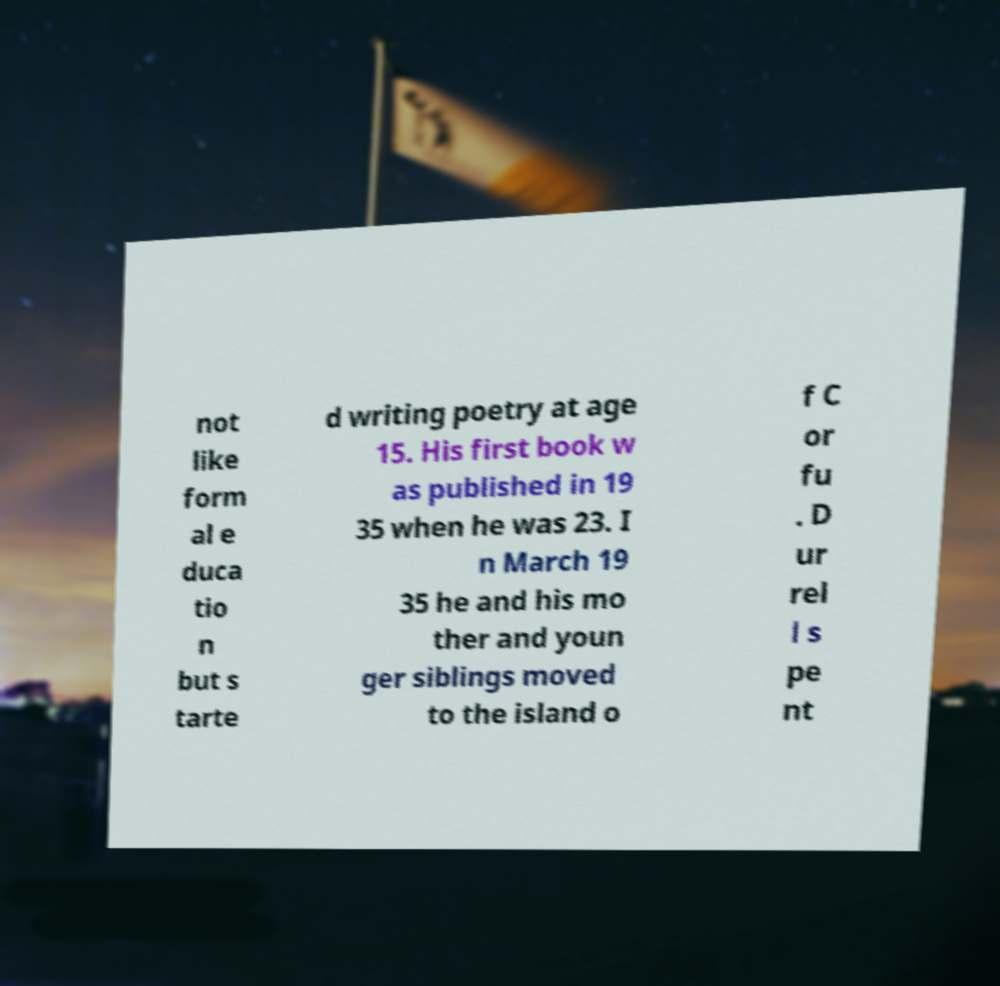Please identify and transcribe the text found in this image. not like form al e duca tio n but s tarte d writing poetry at age 15. His first book w as published in 19 35 when he was 23. I n March 19 35 he and his mo ther and youn ger siblings moved to the island o f C or fu . D ur rel l s pe nt 